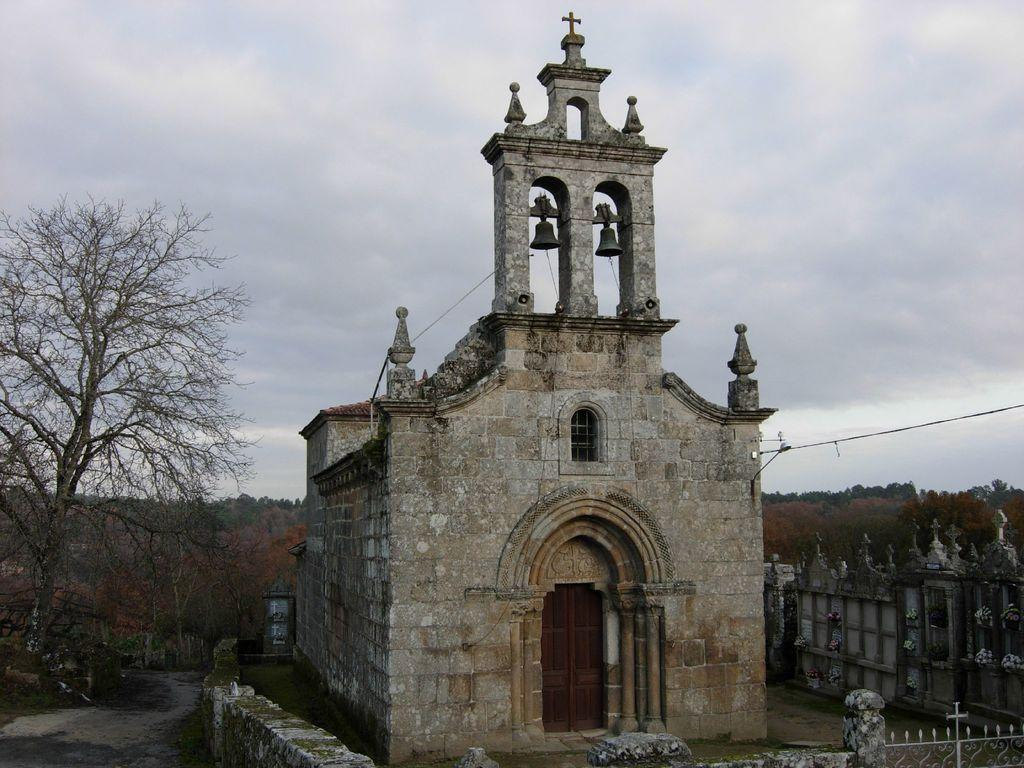What type of structure is present in the image? There is a building in the image. What features can be seen on the building? The building has a window, a door, bells, a wall, and a gate. What can be found outside the building? There are trees in the image. What is visible in the background of the image? The sky is visible in the background of the image, and there are clouds in the sky. What type of nail can be seen in the image? There is no nail present in the image. Is there a knife visible in the image? No, there is no knife visible in the image. 